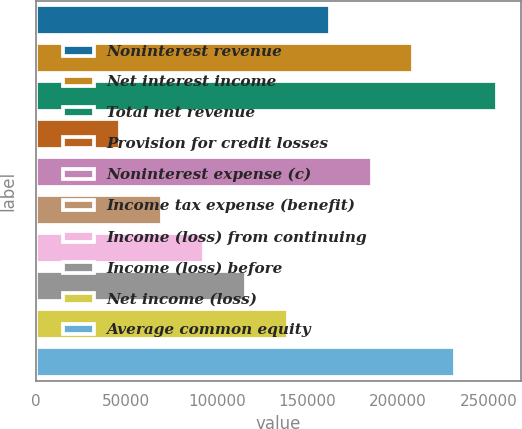Convert chart. <chart><loc_0><loc_0><loc_500><loc_500><bar_chart><fcel>Noninterest revenue<fcel>Net interest income<fcel>Total net revenue<fcel>Provision for credit losses<fcel>Noninterest expense (c)<fcel>Income tax expense (benefit)<fcel>Income (loss) from continuing<fcel>Income (loss) before<fcel>Net income (loss)<fcel>Average common equity<nl><fcel>162103<fcel>208412<fcel>254720<fcel>46330.8<fcel>185257<fcel>69485.2<fcel>92639.6<fcel>115794<fcel>138948<fcel>231566<nl></chart> 